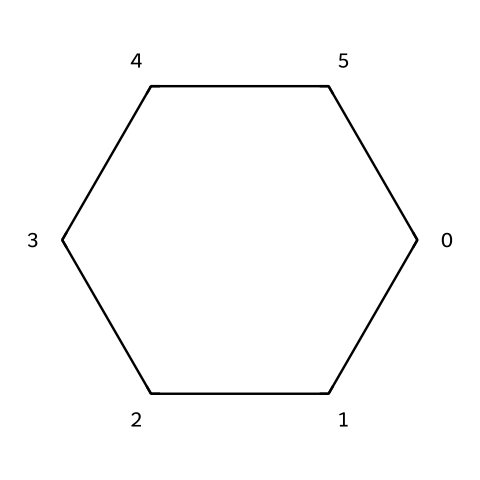What is the molecular formula of cyclohexane? The chemical structure represents cyclohexane, which has six carbon atoms and twelve hydrogen atoms. Therefore, the molecular formula is derived from counting these atoms.
Answer: C6H12 How many carbon atoms are present in cyclohexane? The SMILES representation indicates a cyclohexane structure, which consists of a six-membered carbon ring. By analyzing the SMILES code, we count six carbon atoms.
Answer: 6 What type of chemical compound is cyclohexane? Cyclohexane is identified as a cycloalkane due to its ring structure formed entirely of carbon atoms connected by single bonds. This classification is specific to alkanes that are cyclic in nature.
Answer: cycloalkane How many hydrogen atoms are bonded to each carbon in cyclohexane? In cyclohexane, each carbon atom in the ring is bonded to two hydrogen atoms, which is characteristic of saturated hydrocarbons with single bonds. The molecular formula can confirm this number as there are twelve hydrogen atoms total among six carbons.
Answer: 2 What is the primary type of bond present in cyclohexane? The cyclohexane structure is composed entirely of carbon-carbon single bonds and carbon-hydrogen single bonds, which categorizes it as a saturated hydrocarbon. Identifying the bonds from the SMILES structure shows that it lacks double or triple bonds.
Answer: single Is cyclohexane a saturated or unsaturated hydrocarbon? Saturated hydrocarbons contain only single bonds between carbon atoms with the maximum number of hydrogen atoms per carbon. Cyclohexane fits this definition as it exclusively has single bonds among its carbon valences.
Answer: saturated What type of structure does cyclohexane have? Cyclohexane has a three-dimensional, chair conformation which minimizes steric strain among hydrogen atoms. The structural representation in SMILES suggests a figure that can adopt this orientation despite being linear in molecular formula terms.
Answer: chair 